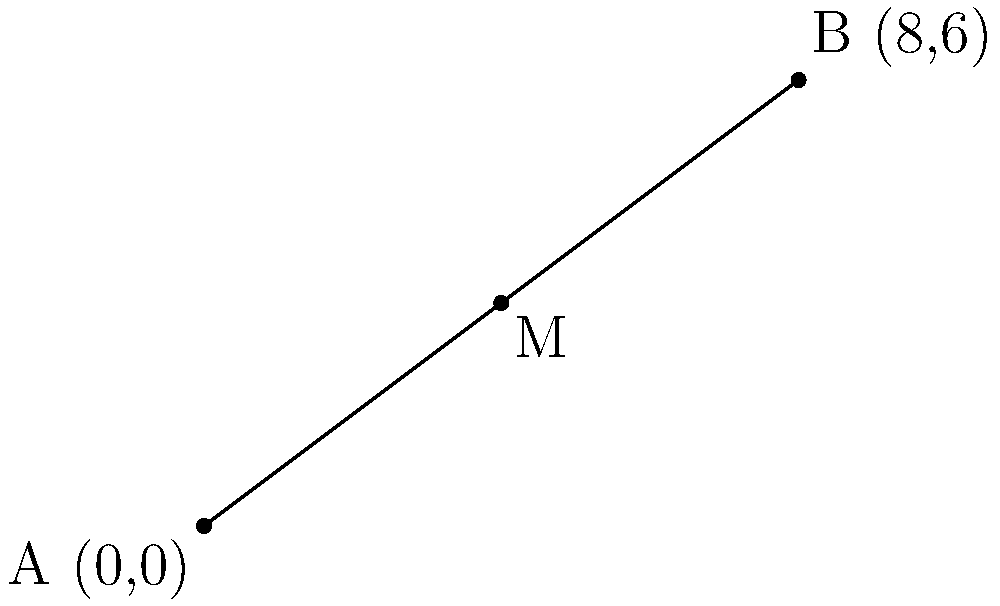Two urban centers are located at coordinates (0,0) and (8,6) on a city map. To determine the optimal location for a new public facility, you need to find the midpoint between these two centers. What are the coordinates of this optimal location? To find the midpoint between two points, we can use the midpoint formula:

$$M_x = \frac{x_1 + x_2}{2}, M_y = \frac{y_1 + y_2}{2}$$

Where $(x_1, y_1)$ are the coordinates of the first point and $(x_2, y_2)$ are the coordinates of the second point.

Given:
- Urban Center 1: $(0, 0)$
- Urban Center 2: $(8, 6)$

Step 1: Calculate the x-coordinate of the midpoint
$$M_x = \frac{0 + 8}{2} = \frac{8}{2} = 4$$

Step 2: Calculate the y-coordinate of the midpoint
$$M_y = \frac{0 + 6}{2} = \frac{6}{2} = 3$$

Therefore, the coordinates of the optimal location (midpoint) are (4, 3).
Answer: (4, 3) 